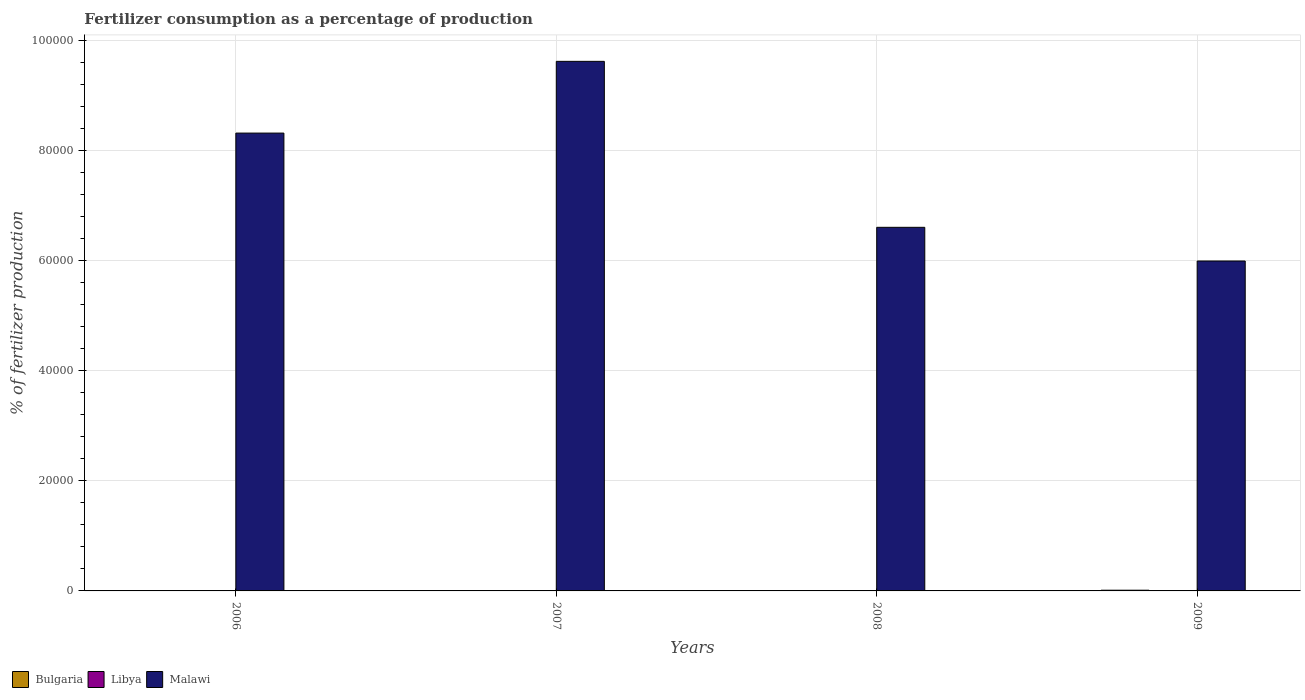Are the number of bars per tick equal to the number of legend labels?
Make the answer very short. Yes. How many bars are there on the 1st tick from the left?
Your response must be concise. 3. What is the percentage of fertilizers consumed in Bulgaria in 2007?
Keep it short and to the point. 67.77. Across all years, what is the maximum percentage of fertilizers consumed in Libya?
Keep it short and to the point. 29.69. Across all years, what is the minimum percentage of fertilizers consumed in Libya?
Make the answer very short. 15.92. In which year was the percentage of fertilizers consumed in Bulgaria minimum?
Provide a short and direct response. 2006. What is the total percentage of fertilizers consumed in Libya in the graph?
Your answer should be compact. 82.31. What is the difference between the percentage of fertilizers consumed in Bulgaria in 2006 and that in 2007?
Give a very brief answer. -9.68. What is the difference between the percentage of fertilizers consumed in Libya in 2007 and the percentage of fertilizers consumed in Malawi in 2009?
Make the answer very short. -5.99e+04. What is the average percentage of fertilizers consumed in Bulgaria per year?
Make the answer very short. 82.77. In the year 2006, what is the difference between the percentage of fertilizers consumed in Bulgaria and percentage of fertilizers consumed in Malawi?
Your answer should be compact. -8.32e+04. What is the ratio of the percentage of fertilizers consumed in Malawi in 2008 to that in 2009?
Make the answer very short. 1.1. Is the difference between the percentage of fertilizers consumed in Bulgaria in 2006 and 2007 greater than the difference between the percentage of fertilizers consumed in Malawi in 2006 and 2007?
Your response must be concise. Yes. What is the difference between the highest and the second highest percentage of fertilizers consumed in Malawi?
Provide a succinct answer. 1.30e+04. What is the difference between the highest and the lowest percentage of fertilizers consumed in Bulgaria?
Provide a succinct answer. 71.88. In how many years, is the percentage of fertilizers consumed in Libya greater than the average percentage of fertilizers consumed in Libya taken over all years?
Offer a terse response. 1. Is the sum of the percentage of fertilizers consumed in Bulgaria in 2006 and 2009 greater than the maximum percentage of fertilizers consumed in Libya across all years?
Your answer should be compact. Yes. What does the 3rd bar from the right in 2008 represents?
Your response must be concise. Bulgaria. Is it the case that in every year, the sum of the percentage of fertilizers consumed in Bulgaria and percentage of fertilizers consumed in Libya is greater than the percentage of fertilizers consumed in Malawi?
Provide a succinct answer. No. Are the values on the major ticks of Y-axis written in scientific E-notation?
Ensure brevity in your answer.  No. Does the graph contain grids?
Offer a very short reply. Yes. How many legend labels are there?
Your answer should be very brief. 3. What is the title of the graph?
Make the answer very short. Fertilizer consumption as a percentage of production. What is the label or title of the X-axis?
Offer a very short reply. Years. What is the label or title of the Y-axis?
Provide a succinct answer. % of fertilizer production. What is the % of fertilizer production in Bulgaria in 2006?
Provide a succinct answer. 58.09. What is the % of fertilizer production of Libya in 2006?
Your answer should be very brief. 19.46. What is the % of fertilizer production in Malawi in 2006?
Keep it short and to the point. 8.32e+04. What is the % of fertilizer production in Bulgaria in 2007?
Offer a very short reply. 67.77. What is the % of fertilizer production of Libya in 2007?
Offer a very short reply. 29.69. What is the % of fertilizer production in Malawi in 2007?
Ensure brevity in your answer.  9.63e+04. What is the % of fertilizer production of Bulgaria in 2008?
Your answer should be compact. 75.26. What is the % of fertilizer production of Libya in 2008?
Give a very brief answer. 17.23. What is the % of fertilizer production of Malawi in 2008?
Give a very brief answer. 6.61e+04. What is the % of fertilizer production of Bulgaria in 2009?
Your answer should be very brief. 129.97. What is the % of fertilizer production in Libya in 2009?
Make the answer very short. 15.92. What is the % of fertilizer production of Malawi in 2009?
Your answer should be very brief. 6.00e+04. Across all years, what is the maximum % of fertilizer production in Bulgaria?
Give a very brief answer. 129.97. Across all years, what is the maximum % of fertilizer production of Libya?
Ensure brevity in your answer.  29.69. Across all years, what is the maximum % of fertilizer production of Malawi?
Offer a very short reply. 9.63e+04. Across all years, what is the minimum % of fertilizer production of Bulgaria?
Your answer should be very brief. 58.09. Across all years, what is the minimum % of fertilizer production in Libya?
Your response must be concise. 15.92. Across all years, what is the minimum % of fertilizer production of Malawi?
Give a very brief answer. 6.00e+04. What is the total % of fertilizer production in Bulgaria in the graph?
Your response must be concise. 331.08. What is the total % of fertilizer production in Libya in the graph?
Provide a short and direct response. 82.31. What is the total % of fertilizer production of Malawi in the graph?
Ensure brevity in your answer.  3.06e+05. What is the difference between the % of fertilizer production in Bulgaria in 2006 and that in 2007?
Offer a terse response. -9.68. What is the difference between the % of fertilizer production in Libya in 2006 and that in 2007?
Offer a very short reply. -10.23. What is the difference between the % of fertilizer production in Malawi in 2006 and that in 2007?
Your response must be concise. -1.30e+04. What is the difference between the % of fertilizer production of Bulgaria in 2006 and that in 2008?
Your answer should be compact. -17.17. What is the difference between the % of fertilizer production in Libya in 2006 and that in 2008?
Ensure brevity in your answer.  2.23. What is the difference between the % of fertilizer production in Malawi in 2006 and that in 2008?
Offer a terse response. 1.71e+04. What is the difference between the % of fertilizer production of Bulgaria in 2006 and that in 2009?
Provide a short and direct response. -71.88. What is the difference between the % of fertilizer production in Libya in 2006 and that in 2009?
Make the answer very short. 3.54. What is the difference between the % of fertilizer production in Malawi in 2006 and that in 2009?
Your answer should be compact. 2.33e+04. What is the difference between the % of fertilizer production in Bulgaria in 2007 and that in 2008?
Offer a very short reply. -7.49. What is the difference between the % of fertilizer production in Libya in 2007 and that in 2008?
Provide a succinct answer. 12.46. What is the difference between the % of fertilizer production in Malawi in 2007 and that in 2008?
Your answer should be compact. 3.02e+04. What is the difference between the % of fertilizer production of Bulgaria in 2007 and that in 2009?
Your response must be concise. -62.2. What is the difference between the % of fertilizer production of Libya in 2007 and that in 2009?
Keep it short and to the point. 13.77. What is the difference between the % of fertilizer production in Malawi in 2007 and that in 2009?
Provide a succinct answer. 3.63e+04. What is the difference between the % of fertilizer production of Bulgaria in 2008 and that in 2009?
Your answer should be very brief. -54.71. What is the difference between the % of fertilizer production of Libya in 2008 and that in 2009?
Your response must be concise. 1.31. What is the difference between the % of fertilizer production in Malawi in 2008 and that in 2009?
Make the answer very short. 6122.77. What is the difference between the % of fertilizer production in Bulgaria in 2006 and the % of fertilizer production in Libya in 2007?
Make the answer very short. 28.4. What is the difference between the % of fertilizer production in Bulgaria in 2006 and the % of fertilizer production in Malawi in 2007?
Offer a terse response. -9.62e+04. What is the difference between the % of fertilizer production in Libya in 2006 and the % of fertilizer production in Malawi in 2007?
Give a very brief answer. -9.63e+04. What is the difference between the % of fertilizer production of Bulgaria in 2006 and the % of fertilizer production of Libya in 2008?
Ensure brevity in your answer.  40.86. What is the difference between the % of fertilizer production in Bulgaria in 2006 and the % of fertilizer production in Malawi in 2008?
Keep it short and to the point. -6.60e+04. What is the difference between the % of fertilizer production of Libya in 2006 and the % of fertilizer production of Malawi in 2008?
Provide a short and direct response. -6.61e+04. What is the difference between the % of fertilizer production in Bulgaria in 2006 and the % of fertilizer production in Libya in 2009?
Make the answer very short. 42.17. What is the difference between the % of fertilizer production of Bulgaria in 2006 and the % of fertilizer production of Malawi in 2009?
Provide a succinct answer. -5.99e+04. What is the difference between the % of fertilizer production in Libya in 2006 and the % of fertilizer production in Malawi in 2009?
Provide a short and direct response. -6.00e+04. What is the difference between the % of fertilizer production of Bulgaria in 2007 and the % of fertilizer production of Libya in 2008?
Provide a short and direct response. 50.54. What is the difference between the % of fertilizer production of Bulgaria in 2007 and the % of fertilizer production of Malawi in 2008?
Provide a succinct answer. -6.60e+04. What is the difference between the % of fertilizer production of Libya in 2007 and the % of fertilizer production of Malawi in 2008?
Provide a succinct answer. -6.61e+04. What is the difference between the % of fertilizer production in Bulgaria in 2007 and the % of fertilizer production in Libya in 2009?
Provide a short and direct response. 51.85. What is the difference between the % of fertilizer production of Bulgaria in 2007 and the % of fertilizer production of Malawi in 2009?
Provide a succinct answer. -5.99e+04. What is the difference between the % of fertilizer production of Libya in 2007 and the % of fertilizer production of Malawi in 2009?
Ensure brevity in your answer.  -5.99e+04. What is the difference between the % of fertilizer production in Bulgaria in 2008 and the % of fertilizer production in Libya in 2009?
Your response must be concise. 59.33. What is the difference between the % of fertilizer production in Bulgaria in 2008 and the % of fertilizer production in Malawi in 2009?
Provide a short and direct response. -5.99e+04. What is the difference between the % of fertilizer production in Libya in 2008 and the % of fertilizer production in Malawi in 2009?
Your answer should be compact. -6.00e+04. What is the average % of fertilizer production in Bulgaria per year?
Keep it short and to the point. 82.77. What is the average % of fertilizer production in Libya per year?
Your answer should be very brief. 20.58. What is the average % of fertilizer production in Malawi per year?
Give a very brief answer. 7.64e+04. In the year 2006, what is the difference between the % of fertilizer production in Bulgaria and % of fertilizer production in Libya?
Make the answer very short. 38.63. In the year 2006, what is the difference between the % of fertilizer production of Bulgaria and % of fertilizer production of Malawi?
Keep it short and to the point. -8.32e+04. In the year 2006, what is the difference between the % of fertilizer production in Libya and % of fertilizer production in Malawi?
Give a very brief answer. -8.32e+04. In the year 2007, what is the difference between the % of fertilizer production of Bulgaria and % of fertilizer production of Libya?
Ensure brevity in your answer.  38.08. In the year 2007, what is the difference between the % of fertilizer production of Bulgaria and % of fertilizer production of Malawi?
Keep it short and to the point. -9.62e+04. In the year 2007, what is the difference between the % of fertilizer production of Libya and % of fertilizer production of Malawi?
Give a very brief answer. -9.62e+04. In the year 2008, what is the difference between the % of fertilizer production in Bulgaria and % of fertilizer production in Libya?
Provide a succinct answer. 58.03. In the year 2008, what is the difference between the % of fertilizer production in Bulgaria and % of fertilizer production in Malawi?
Ensure brevity in your answer.  -6.60e+04. In the year 2008, what is the difference between the % of fertilizer production in Libya and % of fertilizer production in Malawi?
Make the answer very short. -6.61e+04. In the year 2009, what is the difference between the % of fertilizer production in Bulgaria and % of fertilizer production in Libya?
Make the answer very short. 114.04. In the year 2009, what is the difference between the % of fertilizer production in Bulgaria and % of fertilizer production in Malawi?
Provide a short and direct response. -5.98e+04. In the year 2009, what is the difference between the % of fertilizer production of Libya and % of fertilizer production of Malawi?
Provide a succinct answer. -6.00e+04. What is the ratio of the % of fertilizer production of Bulgaria in 2006 to that in 2007?
Your answer should be compact. 0.86. What is the ratio of the % of fertilizer production in Libya in 2006 to that in 2007?
Your response must be concise. 0.66. What is the ratio of the % of fertilizer production in Malawi in 2006 to that in 2007?
Keep it short and to the point. 0.86. What is the ratio of the % of fertilizer production in Bulgaria in 2006 to that in 2008?
Keep it short and to the point. 0.77. What is the ratio of the % of fertilizer production of Libya in 2006 to that in 2008?
Provide a succinct answer. 1.13. What is the ratio of the % of fertilizer production in Malawi in 2006 to that in 2008?
Your response must be concise. 1.26. What is the ratio of the % of fertilizer production of Bulgaria in 2006 to that in 2009?
Keep it short and to the point. 0.45. What is the ratio of the % of fertilizer production of Libya in 2006 to that in 2009?
Offer a terse response. 1.22. What is the ratio of the % of fertilizer production of Malawi in 2006 to that in 2009?
Offer a terse response. 1.39. What is the ratio of the % of fertilizer production in Bulgaria in 2007 to that in 2008?
Your answer should be compact. 0.9. What is the ratio of the % of fertilizer production of Libya in 2007 to that in 2008?
Your answer should be compact. 1.72. What is the ratio of the % of fertilizer production in Malawi in 2007 to that in 2008?
Provide a succinct answer. 1.46. What is the ratio of the % of fertilizer production in Bulgaria in 2007 to that in 2009?
Make the answer very short. 0.52. What is the ratio of the % of fertilizer production in Libya in 2007 to that in 2009?
Offer a very short reply. 1.86. What is the ratio of the % of fertilizer production of Malawi in 2007 to that in 2009?
Provide a succinct answer. 1.61. What is the ratio of the % of fertilizer production in Bulgaria in 2008 to that in 2009?
Offer a terse response. 0.58. What is the ratio of the % of fertilizer production in Libya in 2008 to that in 2009?
Your response must be concise. 1.08. What is the ratio of the % of fertilizer production of Malawi in 2008 to that in 2009?
Keep it short and to the point. 1.1. What is the difference between the highest and the second highest % of fertilizer production of Bulgaria?
Your response must be concise. 54.71. What is the difference between the highest and the second highest % of fertilizer production in Libya?
Keep it short and to the point. 10.23. What is the difference between the highest and the second highest % of fertilizer production of Malawi?
Ensure brevity in your answer.  1.30e+04. What is the difference between the highest and the lowest % of fertilizer production of Bulgaria?
Your answer should be compact. 71.88. What is the difference between the highest and the lowest % of fertilizer production of Libya?
Provide a short and direct response. 13.77. What is the difference between the highest and the lowest % of fertilizer production of Malawi?
Offer a terse response. 3.63e+04. 